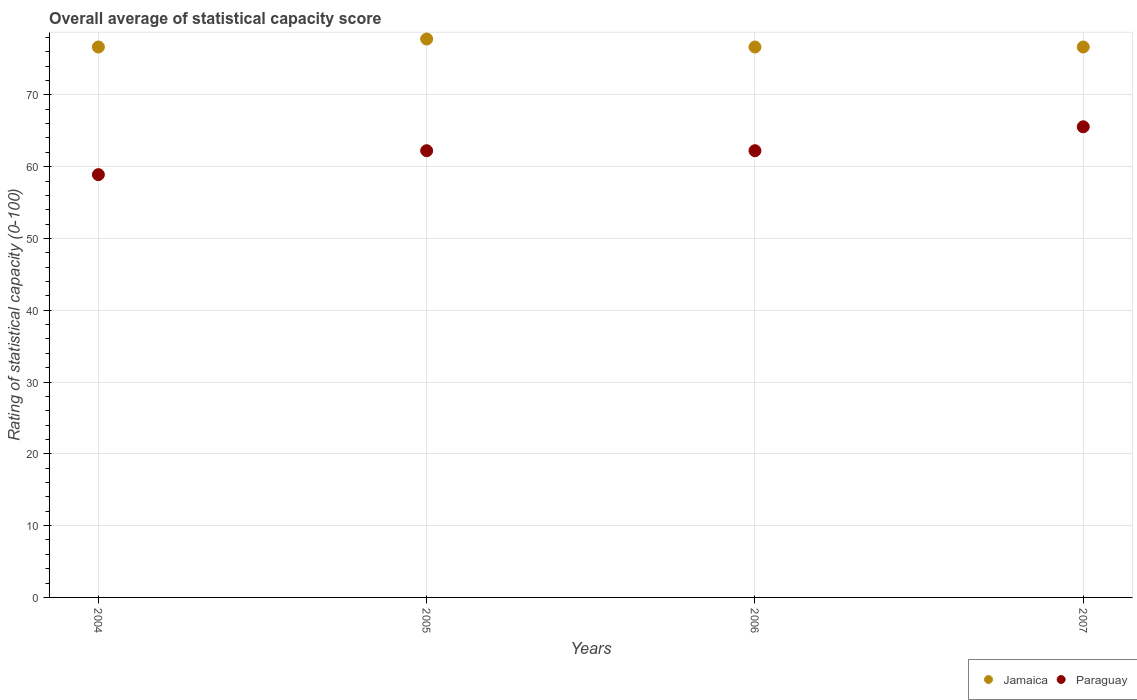Is the number of dotlines equal to the number of legend labels?
Provide a succinct answer. Yes. What is the rating of statistical capacity in Paraguay in 2005?
Keep it short and to the point. 62.22. Across all years, what is the maximum rating of statistical capacity in Jamaica?
Make the answer very short. 77.78. Across all years, what is the minimum rating of statistical capacity in Jamaica?
Provide a short and direct response. 76.67. What is the total rating of statistical capacity in Paraguay in the graph?
Give a very brief answer. 248.89. What is the difference between the rating of statistical capacity in Jamaica in 2005 and that in 2006?
Offer a terse response. 1.11. What is the difference between the rating of statistical capacity in Jamaica in 2005 and the rating of statistical capacity in Paraguay in 2007?
Ensure brevity in your answer.  12.22. What is the average rating of statistical capacity in Jamaica per year?
Your answer should be compact. 76.94. In the year 2005, what is the difference between the rating of statistical capacity in Paraguay and rating of statistical capacity in Jamaica?
Ensure brevity in your answer.  -15.56. What is the ratio of the rating of statistical capacity in Paraguay in 2006 to that in 2007?
Provide a short and direct response. 0.95. Is the difference between the rating of statistical capacity in Paraguay in 2004 and 2005 greater than the difference between the rating of statistical capacity in Jamaica in 2004 and 2005?
Your response must be concise. No. What is the difference between the highest and the second highest rating of statistical capacity in Jamaica?
Provide a short and direct response. 1.11. What is the difference between the highest and the lowest rating of statistical capacity in Jamaica?
Make the answer very short. 1.11. Is the sum of the rating of statistical capacity in Paraguay in 2005 and 2007 greater than the maximum rating of statistical capacity in Jamaica across all years?
Your response must be concise. Yes. Is the rating of statistical capacity in Paraguay strictly greater than the rating of statistical capacity in Jamaica over the years?
Offer a terse response. No. Is the rating of statistical capacity in Paraguay strictly less than the rating of statistical capacity in Jamaica over the years?
Your answer should be very brief. Yes. How many dotlines are there?
Make the answer very short. 2. Does the graph contain any zero values?
Provide a short and direct response. No. Does the graph contain grids?
Keep it short and to the point. Yes. How many legend labels are there?
Your response must be concise. 2. What is the title of the graph?
Ensure brevity in your answer.  Overall average of statistical capacity score. What is the label or title of the Y-axis?
Provide a short and direct response. Rating of statistical capacity (0-100). What is the Rating of statistical capacity (0-100) in Jamaica in 2004?
Your response must be concise. 76.67. What is the Rating of statistical capacity (0-100) of Paraguay in 2004?
Your answer should be very brief. 58.89. What is the Rating of statistical capacity (0-100) in Jamaica in 2005?
Your answer should be compact. 77.78. What is the Rating of statistical capacity (0-100) of Paraguay in 2005?
Your answer should be compact. 62.22. What is the Rating of statistical capacity (0-100) in Jamaica in 2006?
Provide a short and direct response. 76.67. What is the Rating of statistical capacity (0-100) in Paraguay in 2006?
Your response must be concise. 62.22. What is the Rating of statistical capacity (0-100) of Jamaica in 2007?
Your answer should be compact. 76.67. What is the Rating of statistical capacity (0-100) in Paraguay in 2007?
Keep it short and to the point. 65.56. Across all years, what is the maximum Rating of statistical capacity (0-100) in Jamaica?
Ensure brevity in your answer.  77.78. Across all years, what is the maximum Rating of statistical capacity (0-100) of Paraguay?
Your answer should be very brief. 65.56. Across all years, what is the minimum Rating of statistical capacity (0-100) in Jamaica?
Offer a terse response. 76.67. Across all years, what is the minimum Rating of statistical capacity (0-100) in Paraguay?
Offer a very short reply. 58.89. What is the total Rating of statistical capacity (0-100) in Jamaica in the graph?
Your answer should be very brief. 307.78. What is the total Rating of statistical capacity (0-100) in Paraguay in the graph?
Your answer should be compact. 248.89. What is the difference between the Rating of statistical capacity (0-100) in Jamaica in 2004 and that in 2005?
Provide a short and direct response. -1.11. What is the difference between the Rating of statistical capacity (0-100) in Paraguay in 2004 and that in 2006?
Offer a very short reply. -3.33. What is the difference between the Rating of statistical capacity (0-100) of Jamaica in 2004 and that in 2007?
Give a very brief answer. 0. What is the difference between the Rating of statistical capacity (0-100) in Paraguay in 2004 and that in 2007?
Give a very brief answer. -6.67. What is the difference between the Rating of statistical capacity (0-100) of Jamaica in 2005 and that in 2006?
Give a very brief answer. 1.11. What is the difference between the Rating of statistical capacity (0-100) of Paraguay in 2005 and that in 2006?
Offer a very short reply. 0. What is the difference between the Rating of statistical capacity (0-100) of Jamaica in 2006 and that in 2007?
Ensure brevity in your answer.  0. What is the difference between the Rating of statistical capacity (0-100) of Paraguay in 2006 and that in 2007?
Your answer should be compact. -3.33. What is the difference between the Rating of statistical capacity (0-100) of Jamaica in 2004 and the Rating of statistical capacity (0-100) of Paraguay in 2005?
Provide a short and direct response. 14.44. What is the difference between the Rating of statistical capacity (0-100) of Jamaica in 2004 and the Rating of statistical capacity (0-100) of Paraguay in 2006?
Offer a terse response. 14.44. What is the difference between the Rating of statistical capacity (0-100) in Jamaica in 2004 and the Rating of statistical capacity (0-100) in Paraguay in 2007?
Ensure brevity in your answer.  11.11. What is the difference between the Rating of statistical capacity (0-100) of Jamaica in 2005 and the Rating of statistical capacity (0-100) of Paraguay in 2006?
Provide a short and direct response. 15.56. What is the difference between the Rating of statistical capacity (0-100) of Jamaica in 2005 and the Rating of statistical capacity (0-100) of Paraguay in 2007?
Give a very brief answer. 12.22. What is the difference between the Rating of statistical capacity (0-100) in Jamaica in 2006 and the Rating of statistical capacity (0-100) in Paraguay in 2007?
Your answer should be very brief. 11.11. What is the average Rating of statistical capacity (0-100) of Jamaica per year?
Your answer should be compact. 76.94. What is the average Rating of statistical capacity (0-100) in Paraguay per year?
Keep it short and to the point. 62.22. In the year 2004, what is the difference between the Rating of statistical capacity (0-100) in Jamaica and Rating of statistical capacity (0-100) in Paraguay?
Offer a very short reply. 17.78. In the year 2005, what is the difference between the Rating of statistical capacity (0-100) in Jamaica and Rating of statistical capacity (0-100) in Paraguay?
Offer a very short reply. 15.56. In the year 2006, what is the difference between the Rating of statistical capacity (0-100) of Jamaica and Rating of statistical capacity (0-100) of Paraguay?
Your answer should be compact. 14.44. In the year 2007, what is the difference between the Rating of statistical capacity (0-100) in Jamaica and Rating of statistical capacity (0-100) in Paraguay?
Offer a terse response. 11.11. What is the ratio of the Rating of statistical capacity (0-100) of Jamaica in 2004 to that in 2005?
Your answer should be compact. 0.99. What is the ratio of the Rating of statistical capacity (0-100) in Paraguay in 2004 to that in 2005?
Offer a terse response. 0.95. What is the ratio of the Rating of statistical capacity (0-100) in Jamaica in 2004 to that in 2006?
Your answer should be very brief. 1. What is the ratio of the Rating of statistical capacity (0-100) of Paraguay in 2004 to that in 2006?
Provide a short and direct response. 0.95. What is the ratio of the Rating of statistical capacity (0-100) in Paraguay in 2004 to that in 2007?
Make the answer very short. 0.9. What is the ratio of the Rating of statistical capacity (0-100) in Jamaica in 2005 to that in 2006?
Give a very brief answer. 1.01. What is the ratio of the Rating of statistical capacity (0-100) of Paraguay in 2005 to that in 2006?
Your response must be concise. 1. What is the ratio of the Rating of statistical capacity (0-100) in Jamaica in 2005 to that in 2007?
Give a very brief answer. 1.01. What is the ratio of the Rating of statistical capacity (0-100) of Paraguay in 2005 to that in 2007?
Your answer should be very brief. 0.95. What is the ratio of the Rating of statistical capacity (0-100) of Jamaica in 2006 to that in 2007?
Make the answer very short. 1. What is the ratio of the Rating of statistical capacity (0-100) in Paraguay in 2006 to that in 2007?
Your answer should be very brief. 0.95. What is the difference between the highest and the second highest Rating of statistical capacity (0-100) in Jamaica?
Offer a very short reply. 1.11. What is the difference between the highest and the second highest Rating of statistical capacity (0-100) of Paraguay?
Keep it short and to the point. 3.33. What is the difference between the highest and the lowest Rating of statistical capacity (0-100) in Jamaica?
Make the answer very short. 1.11. 